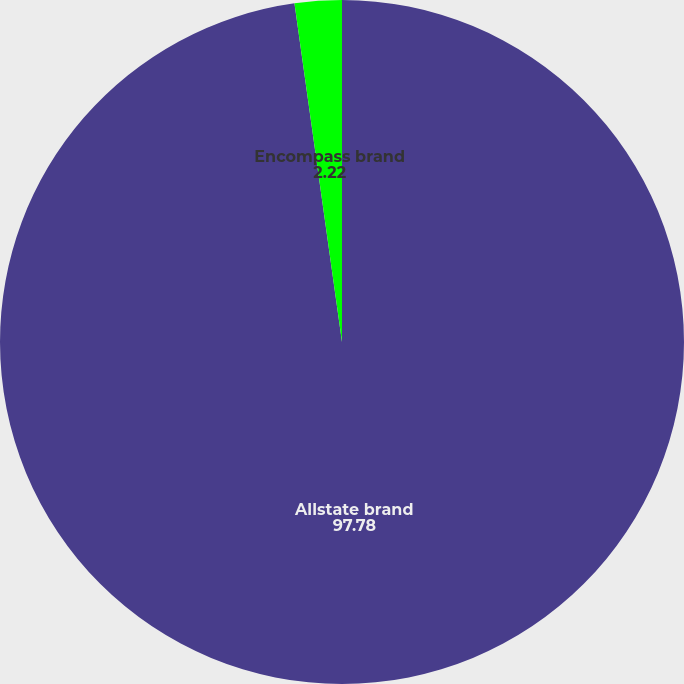Convert chart. <chart><loc_0><loc_0><loc_500><loc_500><pie_chart><fcel>Allstate brand<fcel>Encompass brand<nl><fcel>97.78%<fcel>2.22%<nl></chart> 